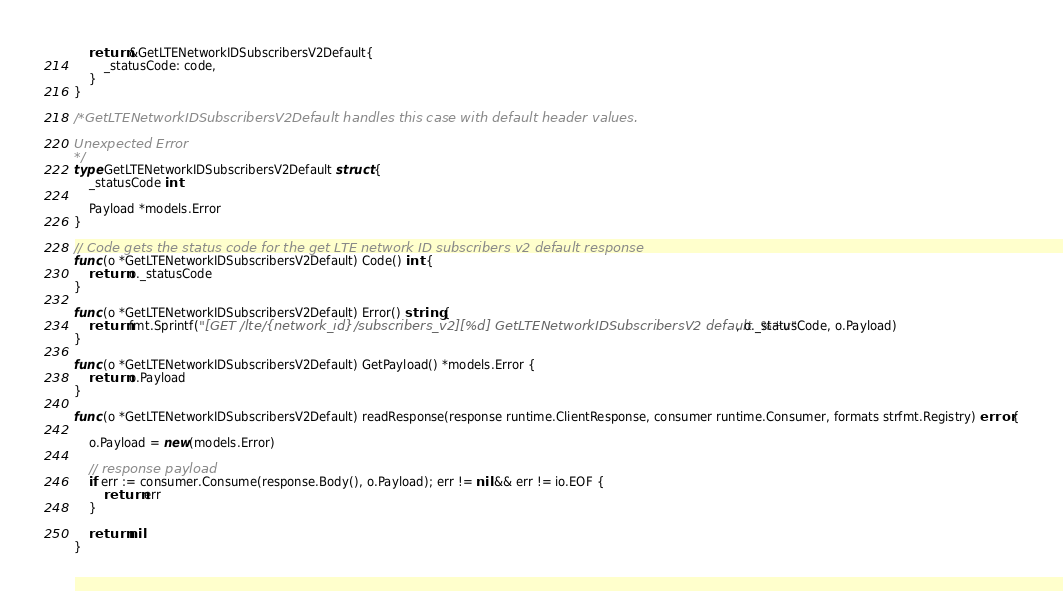<code> <loc_0><loc_0><loc_500><loc_500><_Go_>	return &GetLTENetworkIDSubscribersV2Default{
		_statusCode: code,
	}
}

/*GetLTENetworkIDSubscribersV2Default handles this case with default header values.

Unexpected Error
*/
type GetLTENetworkIDSubscribersV2Default struct {
	_statusCode int

	Payload *models.Error
}

// Code gets the status code for the get LTE network ID subscribers v2 default response
func (o *GetLTENetworkIDSubscribersV2Default) Code() int {
	return o._statusCode
}

func (o *GetLTENetworkIDSubscribersV2Default) Error() string {
	return fmt.Sprintf("[GET /lte/{network_id}/subscribers_v2][%d] GetLTENetworkIDSubscribersV2 default  %+v", o._statusCode, o.Payload)
}

func (o *GetLTENetworkIDSubscribersV2Default) GetPayload() *models.Error {
	return o.Payload
}

func (o *GetLTENetworkIDSubscribersV2Default) readResponse(response runtime.ClientResponse, consumer runtime.Consumer, formats strfmt.Registry) error {

	o.Payload = new(models.Error)

	// response payload
	if err := consumer.Consume(response.Body(), o.Payload); err != nil && err != io.EOF {
		return err
	}

	return nil
}
</code> 